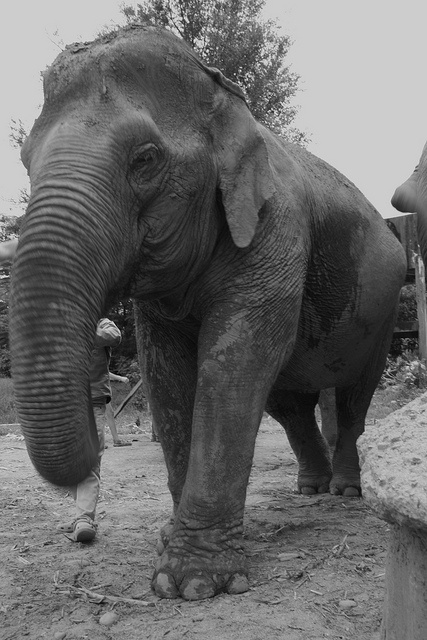Describe the objects in this image and their specific colors. I can see elephant in lightgray, black, and gray tones, people in lightgray, black, gray, and darkgray tones, and elephant in lightgray, gray, and black tones in this image. 